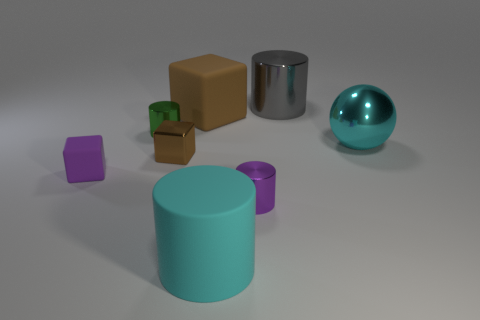Subtract all large gray cylinders. How many cylinders are left? 3 Add 1 green cylinders. How many objects exist? 9 Subtract all green cylinders. How many cylinders are left? 3 Subtract all spheres. How many objects are left? 7 Subtract all gray balls. How many red cylinders are left? 0 Subtract all large cyan rubber cylinders. Subtract all cubes. How many objects are left? 4 Add 4 tiny cylinders. How many tiny cylinders are left? 6 Add 5 balls. How many balls exist? 6 Subtract 0 red spheres. How many objects are left? 8 Subtract 1 balls. How many balls are left? 0 